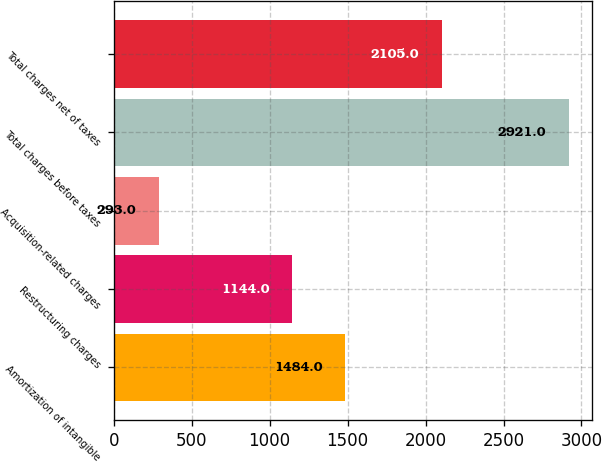<chart> <loc_0><loc_0><loc_500><loc_500><bar_chart><fcel>Amortization of intangible<fcel>Restructuring charges<fcel>Acquisition-related charges<fcel>Total charges before taxes<fcel>Total charges net of taxes<nl><fcel>1484<fcel>1144<fcel>293<fcel>2921<fcel>2105<nl></chart> 